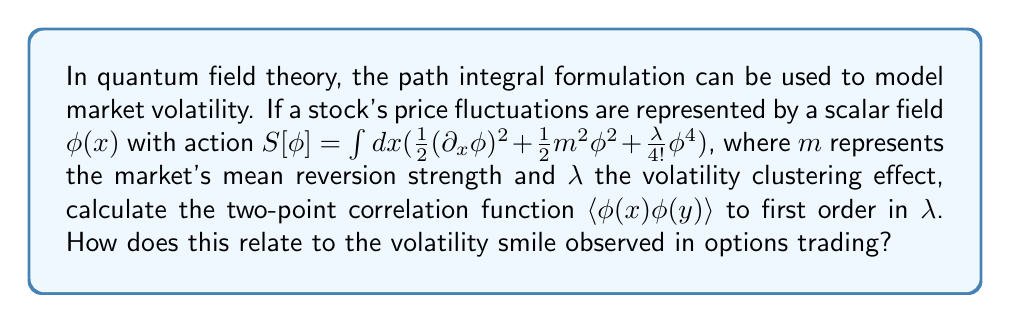What is the answer to this math problem? To solve this problem, we'll follow these steps:

1) The two-point correlation function in quantum field theory is given by:

   $$\langle \phi(x) \phi(y) \rangle = \frac{\int D\phi \, \phi(x) \phi(y) e^{-S[\phi]}}{\int D\phi \, e^{-S[\phi]}}$$

2) Expand the exponential to first order in $\lambda$:

   $$e^{-S[\phi]} \approx e^{-S_0[\phi]} (1 - \frac{\lambda}{4!} \int dz \, \phi^4(z))$$

   where $S_0[\phi] = \int dx (\frac{1}{2}(\partial_x \phi)^2 + \frac{1}{2}m^2\phi^2)$

3) The zeroth-order term gives the free propagator:

   $$\langle \phi(x) \phi(y) \rangle_0 = \int \frac{dp}{2\pi} \frac{e^{ip(x-y)}}{p^2 + m^2}$$

4) The first-order correction is:

   $$-\frac{\lambda}{4!} \int dz \langle \phi(x) \phi(y) \phi^4(z) \rangle_0$$

5) Using Wick's theorem, this expands to:

   $$-\frac{\lambda}{2} \int dz \langle \phi(x) \phi(z) \rangle_0 \langle \phi(y) \phi(z) \rangle_0 \langle \phi(z) \phi(z) \rangle_0$$

6) Substituting the free propagator:

   $$-\frac{\lambda}{2} \int dz \int \frac{dp_1}{2\pi} \frac{e^{ip_1(x-z)}}{p_1^2 + m^2} \int \frac{dp_2}{2\pi} \frac{e^{ip_2(y-z)}}{p_2^2 + m^2} \int \frac{dp_3}{2\pi} \frac{1}{p_3^2 + m^2}$$

7) The $z$ integral gives a delta function $(2\pi)\delta(p_1+p_2)$. After integration:

   $$-\frac{\lambda}{4\pi} e^{-m|x-y|} \int \frac{dp}{2\pi} \frac{1}{p^2 + m^2}$$

8) The final integral evaluates to $\frac{1}{2m}$, giving the correction:

   $$-\frac{\lambda}{8\pi m} e^{-m|x-y|}$$

9) Therefore, to first order in $\lambda$:

   $$\langle \phi(x) \phi(y) \rangle \approx \frac{1}{2m}e^{-m|x-y|} (1 - \frac{\lambda}{4\pi m} + O(\lambda^2))$$

This result relates to the volatility smile in options trading. The exponential decay $e^{-m|x-y|}$ represents the mean reversion in stock prices, while the $\lambda$ term introduces skewness and kurtosis, which are characteristics of the volatility smile. Higher $\lambda$ increases the probability of large price movements, corresponding to higher implied volatilities for out-of-the-money options.
Answer: $\frac{1}{2m}e^{-m|x-y|} (1 - \frac{\lambda}{4\pi m})$ 